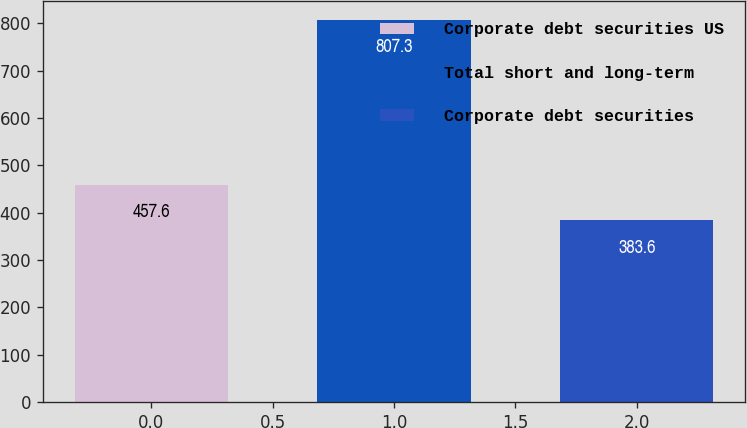Convert chart. <chart><loc_0><loc_0><loc_500><loc_500><bar_chart><fcel>Corporate debt securities US<fcel>Total short and long-term<fcel>Corporate debt securities<nl><fcel>457.6<fcel>807.3<fcel>383.6<nl></chart> 